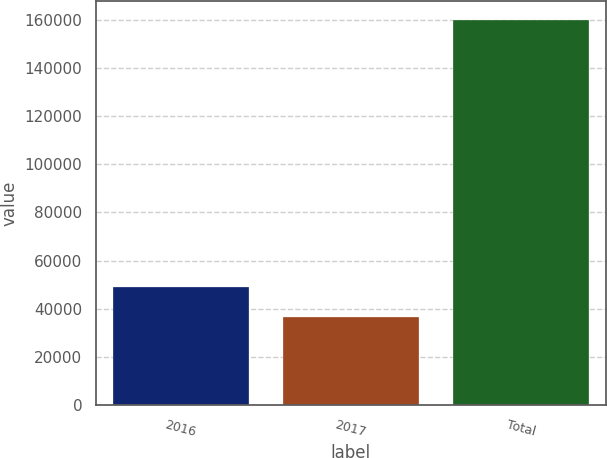<chart> <loc_0><loc_0><loc_500><loc_500><bar_chart><fcel>2016<fcel>2017<fcel>Total<nl><fcel>49091.3<fcel>36764<fcel>160037<nl></chart> 